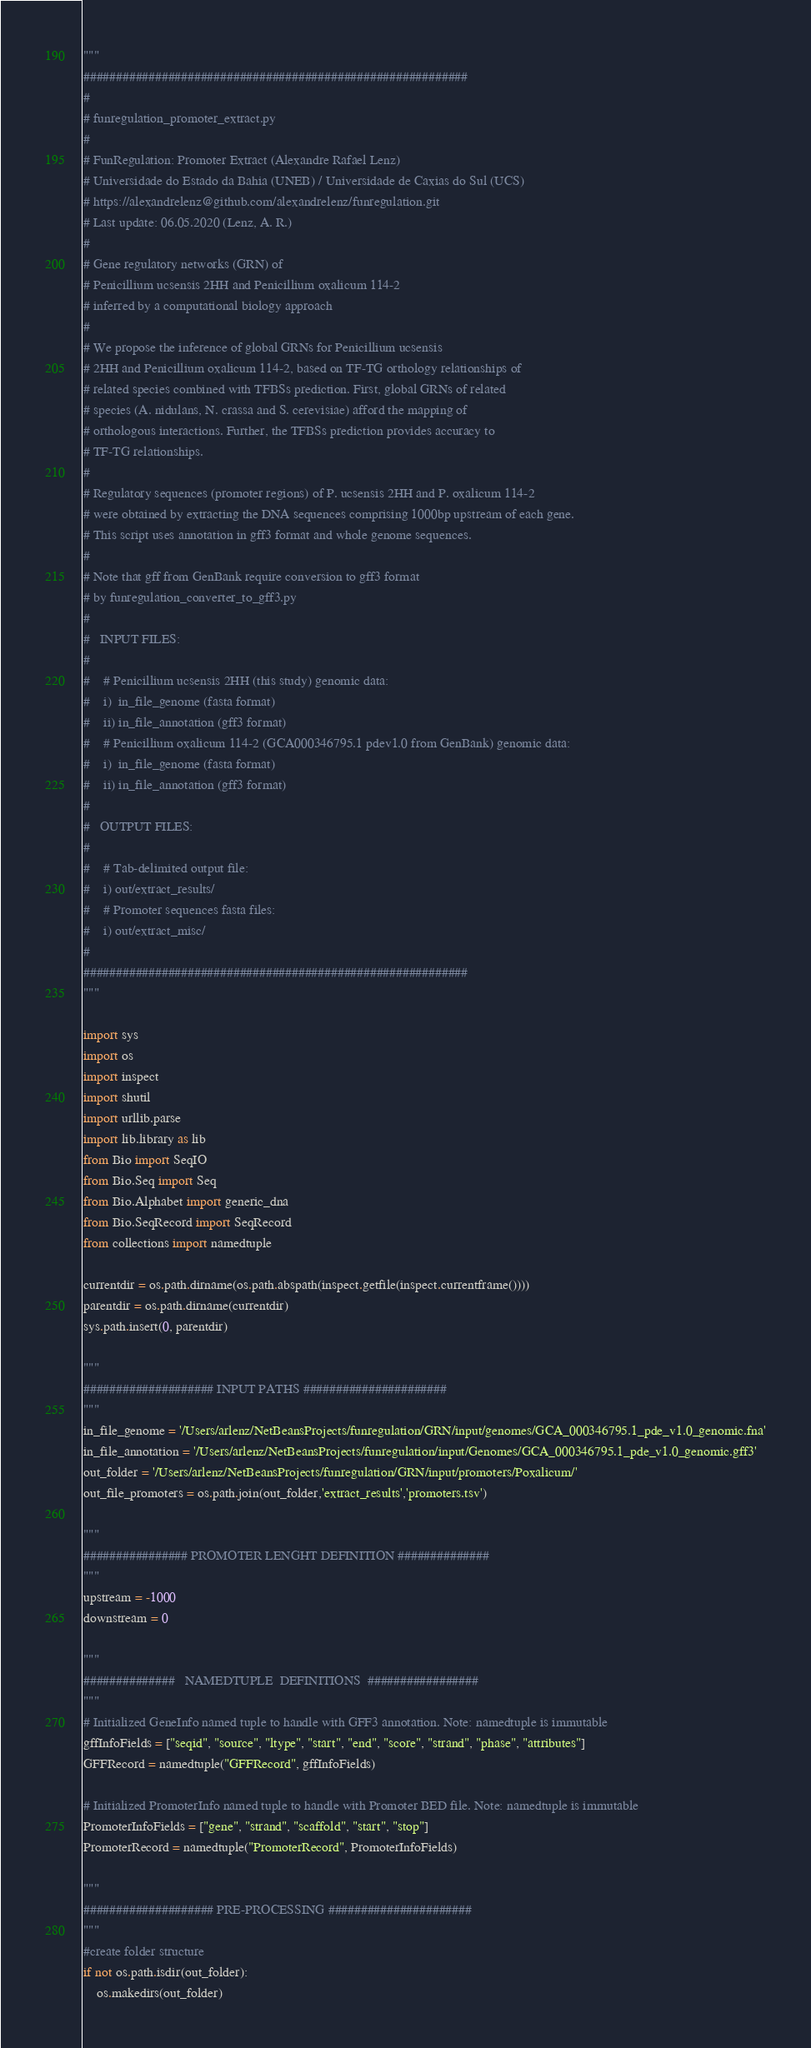Convert code to text. <code><loc_0><loc_0><loc_500><loc_500><_Python_>"""
###########################################################
#
# funregulation_promoter_extract.py
#
# FunRegulation: Promoter Extract (Alexandre Rafael Lenz)
# Universidade do Estado da Bahia (UNEB) / Universidade de Caxias do Sul (UCS)
# https://alexandrelenz@github.com/alexandrelenz/funregulation.git
# Last update: 06.05.2020 (Lenz, A. R.)
#
# Gene regulatory networks (GRN) of 
# Penicillium ucsensis 2HH and Penicillium oxalicum 114-2 
# inferred by a computational biology approach
#
# We propose the inference of global GRNs for Penicillium ucsensis
# 2HH and Penicillium oxalicum 114-2, based on TF-TG orthology relationships of
# related species combined with TFBSs prediction. First, global GRNs of related
# species (A. nidulans, N. crassa and S. cerevisiae) afford the mapping of
# orthologous interactions. Further, the TFBSs prediction provides accuracy to
# TF-TG relationships.
#
# Regulatory sequences (promoter regions) of P. ucsensis 2HH and P. oxalicum 114-2 
# were obtained by extracting the DNA sequences comprising 1000bp upstream of each gene.
# This script uses annotation in gff3 format and whole genome sequences.
#
# Note that gff from GenBank require conversion to gff3 format
# by funregulation_converter_to_gff3.py
#
#   INPUT FILES:
#
#    # Penicillium ucsensis 2HH (this study) genomic data:
#    i)  in_file_genome (fasta format)
#    ii) in_file_annotation (gff3 format)
#    # Penicillium oxalicum 114-2 (GCA000346795.1 pdev1.0 from GenBank) genomic data:
#    i)  in_file_genome (fasta format)
#    ii) in_file_annotation (gff3 format)
#    
#   OUTPUT FILES:
#    
#    # Tab-delimited output file:
#    i) out/extract_results/
#    # Promoter sequences fasta files:
#    i) out/extract_misc/
#
###########################################################
"""

import sys
import os
import inspect
import shutil
import urllib.parse
import lib.library as lib
from Bio import SeqIO
from Bio.Seq import Seq
from Bio.Alphabet import generic_dna
from Bio.SeqRecord import SeqRecord
from collections import namedtuple

currentdir = os.path.dirname(os.path.abspath(inspect.getfile(inspect.currentframe())))
parentdir = os.path.dirname(currentdir)
sys.path.insert(0, parentdir)

"""
#################### INPUT PATHS ######################
"""
in_file_genome = '/Users/arlenz/NetBeansProjects/funregulation/GRN/input/genomes/GCA_000346795.1_pde_v1.0_genomic.fna'
in_file_annotation = '/Users/arlenz/NetBeansProjects/funregulation/input/Genomes/GCA_000346795.1_pde_v1.0_genomic.gff3'
out_folder = '/Users/arlenz/NetBeansProjects/funregulation/GRN/input/promoters/Poxalicum/'
out_file_promoters = os.path.join(out_folder,'extract_results','promoters.tsv')

"""
################ PROMOTER LENGHT DEFINITION ##############
"""
upstream = -1000
downstream = 0

"""
##############   NAMEDTUPLE  DEFINITIONS  #################
"""
# Initialized GeneInfo named tuple to handle with GFF3 annotation. Note: namedtuple is immutable
gffInfoFields = ["seqid", "source", "ltype", "start", "end", "score", "strand", "phase", "attributes"]
GFFRecord = namedtuple("GFFRecord", gffInfoFields)

# Initialized PromoterInfo named tuple to handle with Promoter BED file. Note: namedtuple is immutable
PromoterInfoFields = ["gene", "strand", "scaffold", "start", "stop"]
PromoterRecord = namedtuple("PromoterRecord", PromoterInfoFields)

"""
#################### PRE-PROCESSING ######################
"""
#create folder structure
if not os.path.isdir(out_folder):
    os.makedirs(out_folder)</code> 